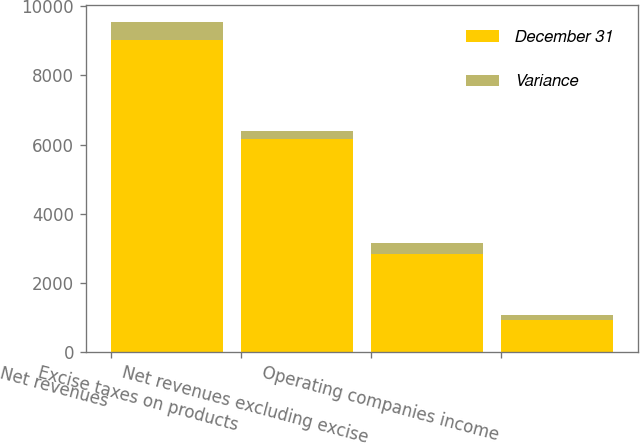<chart> <loc_0><loc_0><loc_500><loc_500><stacked_bar_chart><ecel><fcel>Net revenues<fcel>Excise taxes on products<fcel>Net revenues excluding excise<fcel>Operating companies income<nl><fcel>December 31<fcel>9007<fcel>6165<fcel>2842<fcel>938<nl><fcel>Variance<fcel>541<fcel>224<fcel>317<fcel>147<nl></chart> 